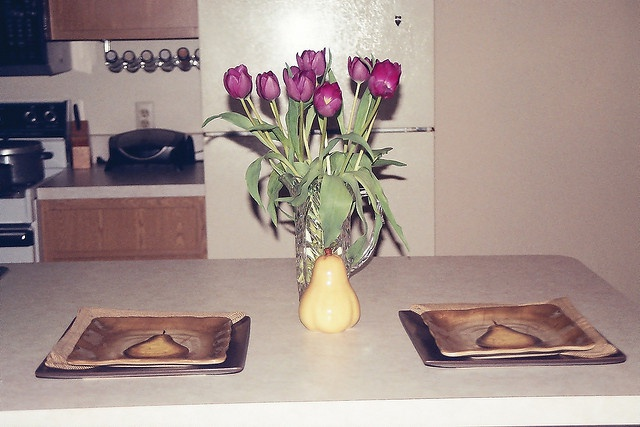Describe the objects in this image and their specific colors. I can see dining table in black, darkgray, gray, ivory, and tan tones, refrigerator in black, lightgray, and darkgray tones, oven in black, darkgray, and gray tones, vase in black, gray, and darkgray tones, and toaster in black and gray tones in this image. 